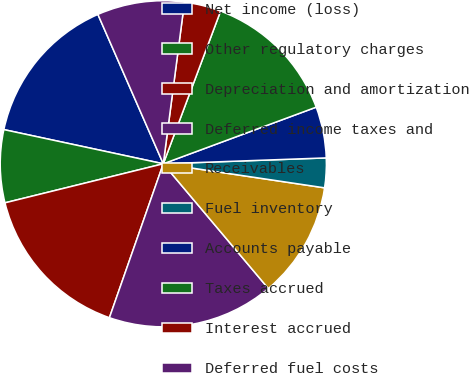<chart> <loc_0><loc_0><loc_500><loc_500><pie_chart><fcel>Net income (loss)<fcel>Other regulatory charges<fcel>Depreciation and amortization<fcel>Deferred income taxes and<fcel>Receivables<fcel>Fuel inventory<fcel>Accounts payable<fcel>Taxes accrued<fcel>Interest accrued<fcel>Deferred fuel costs<nl><fcel>15.07%<fcel>7.21%<fcel>15.79%<fcel>16.5%<fcel>11.5%<fcel>2.93%<fcel>5.07%<fcel>13.64%<fcel>3.64%<fcel>8.64%<nl></chart> 